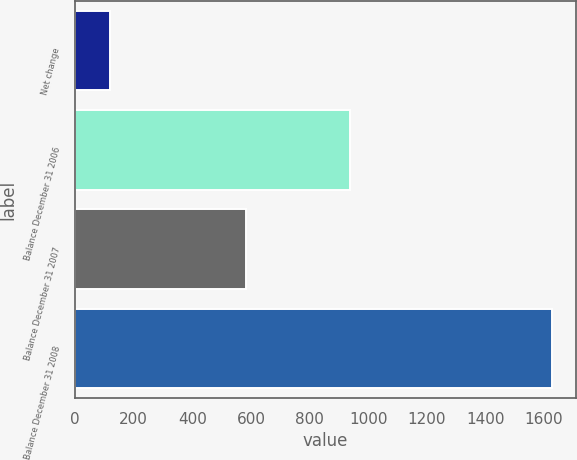<chart> <loc_0><loc_0><loc_500><loc_500><bar_chart><fcel>Net change<fcel>Balance December 31 2006<fcel>Balance December 31 2007<fcel>Balance December 31 2008<nl><fcel>120<fcel>939<fcel>582<fcel>1628<nl></chart> 